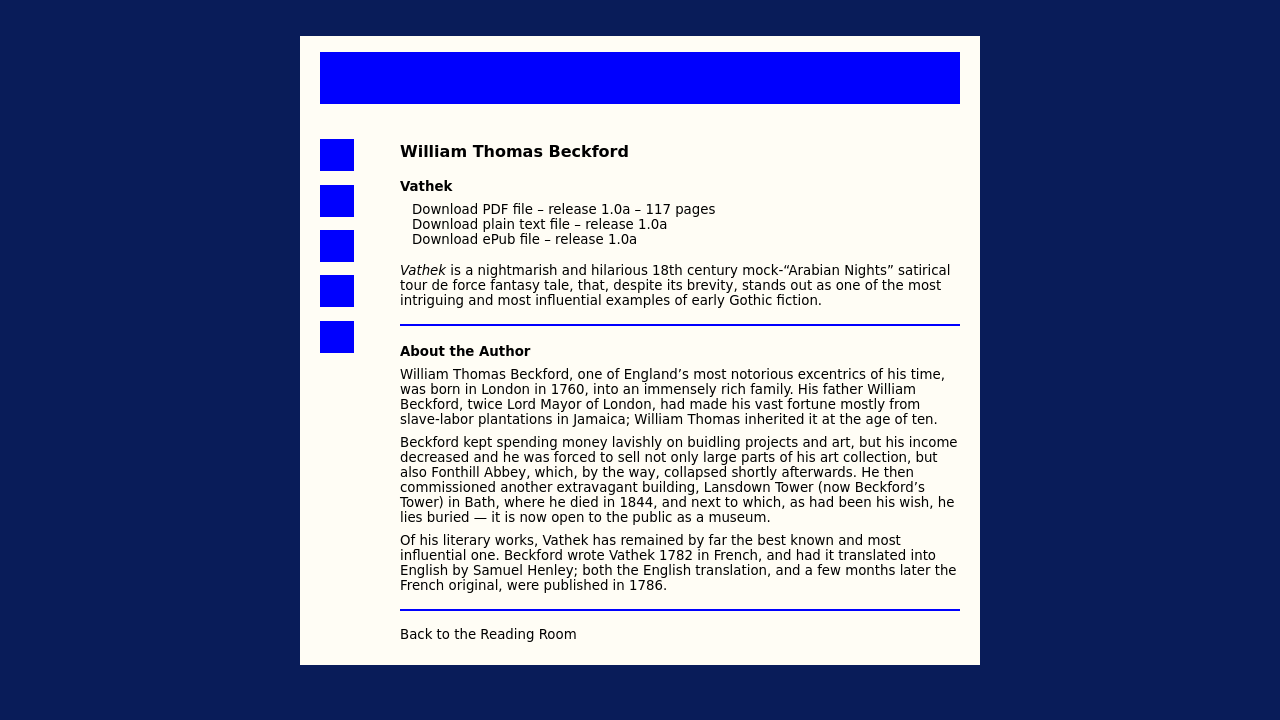What's the procedure for constructing this website from scratch with HTML? <!DOCTYPE html>
<html>
<head>
  <title>William Thomas Beckford - Vathek</title>
  <meta charset="utf-8">
  <meta name="viewport" content="width=device-width, initial-scale=1">
  <link rel="stylesheet" href="https://stackpath.bootstrapcdn.com/bootstrap/4.3.1/css/bootstrap.min.css">
</head>
<body>
  <div class="container mt-4">
    <header class="text-center">
      <h1>William Thomas Beckford</h1>
      <p>Author of Vathek</p>
    </header>
    <section class="mt-3">
      <h2>Vathek</h2>
      <p>Vathek is a nightmarish and hilarious 18th century mock-"Arabian Nights" satirical tour de force fantasy tale...</p>
    </section>
    <section class="mt-3">
      <h2>About the Author</h2>
      <p>William Thomas Beckford, one of England’s most notorious eccentrics...</p>
    </section>
    <footer class="text-center mt-4">
      <p>Back to the Reading Room</p>
    </footer>
  </div>
</body>
</html> 